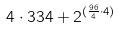<formula> <loc_0><loc_0><loc_500><loc_500>4 \cdot 3 3 4 + 2 ^ { ( \frac { 9 6 } { 4 } \cdot 4 ) }</formula> 